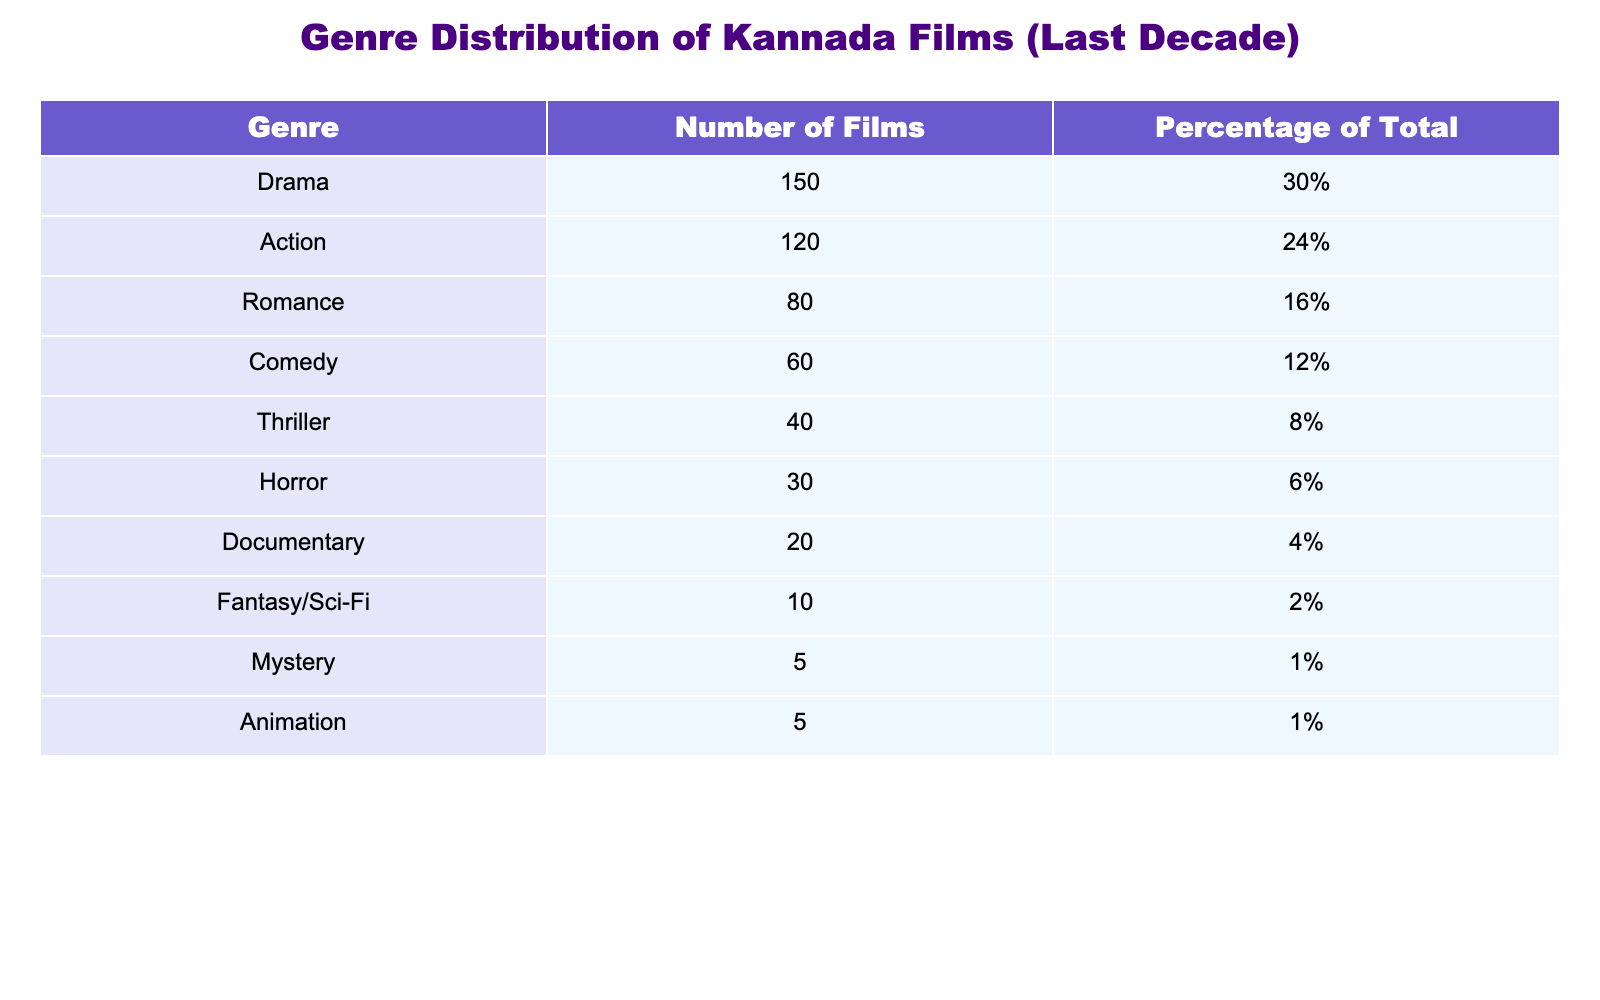What is the total number of Kannada films released in the last decade? To find the total number of films, we need to sum the "Number of Films" across all genres: 150 + 120 + 80 + 60 + 40 + 30 + 20 + 10 + 5 + 5 = 510.
Answer: 510 Which genre has the highest number of films? By looking at the "Number of Films" column, the genre with the highest number is Drama, which has 150 films.
Answer: Drama Is the percentage of Action films greater than that of Thriller films? The percentage of Action films is 24% and for Thriller films, it is 8%. Since 24% is greater than 8%, the statement is true.
Answer: Yes What is the average percentage of films for Comedy and Horror genres combined? To find the average percentage, we first add the percentages of Comedy (12%) and Horror (6%) to get 12 + 6 = 18. Then we divide by 2 (the number of genres) to find the average: 18/2 = 9%.
Answer: 9% How many more Romance films are there compared to Documentary films? The number of Romance films is 80 and for Documentary films, it is 20. Subtracting these gives us 80 - 20 = 60.
Answer: 60 Are there any genres that have an equal number of films? There are two genres with an equal number of films: both Animation and Mystery each have 5 films.
Answer: Yes What percentage of the total films do Horror and Thriller genres represent together? The percentage for Horror is 6% and for Thriller is 8%. Adding these percentages gives us 6 + 8 = 14%.
Answer: 14% Which genre has the lowest number of films, and how many films does it have? The genres with the lowest numbers of films are Mystery and Animation, both with 5 films each, which is the lowest.
Answer: Mystery/Animation, 5 How does the percentage of Drama films compare with the combined percentage of the Comedy and Horror films? The percentage of Drama films is 30%, while the combined percentage of Comedy (12%) and Horror (6%) is 12 + 6 = 18%. Since 30% is greater than 18%, Drama has a higher percentage.
Answer: Yes 